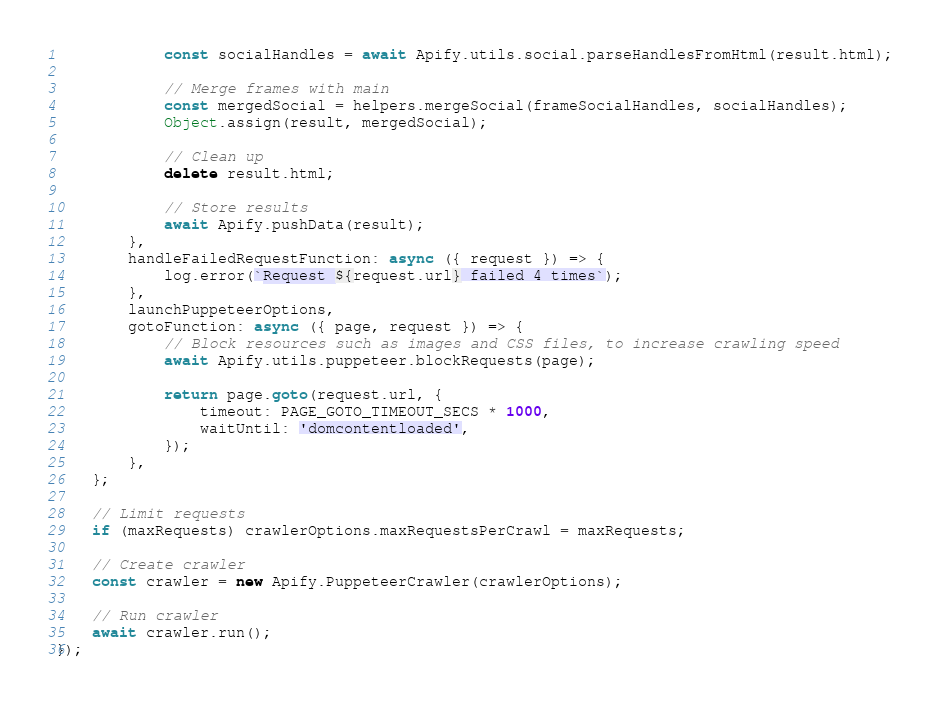<code> <loc_0><loc_0><loc_500><loc_500><_JavaScript_>            const socialHandles = await Apify.utils.social.parseHandlesFromHtml(result.html);

            // Merge frames with main
            const mergedSocial = helpers.mergeSocial(frameSocialHandles, socialHandles);
            Object.assign(result, mergedSocial);

            // Clean up
            delete result.html;

            // Store results
            await Apify.pushData(result);
        },
        handleFailedRequestFunction: async ({ request }) => {
            log.error(`Request ${request.url} failed 4 times`);
        },
        launchPuppeteerOptions,
        gotoFunction: async ({ page, request }) => {
            // Block resources such as images and CSS files, to increase crawling speed
            await Apify.utils.puppeteer.blockRequests(page);

            return page.goto(request.url, {
                timeout: PAGE_GOTO_TIMEOUT_SECS * 1000,
                waitUntil: 'domcontentloaded',
            });
        },
    };

    // Limit requests
    if (maxRequests) crawlerOptions.maxRequestsPerCrawl = maxRequests;

    // Create crawler
    const crawler = new Apify.PuppeteerCrawler(crawlerOptions);

    // Run crawler
    await crawler.run();
});
</code> 